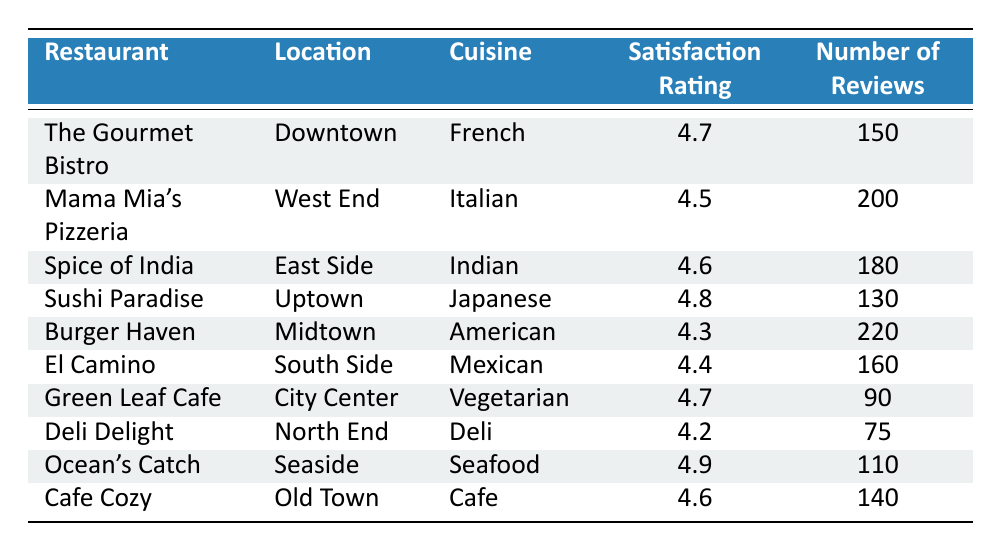What is the highest customer satisfaction rating among the restaurants? The table lists customer satisfaction ratings, and the highest value is 4.9, which is for Ocean's Catch.
Answer: 4.9 Which restaurant has the lowest number of reviews? By examining the 'Number of Reviews' column, Deli Delight has the lowest count with 75 reviews.
Answer: 75 How many more reviews does Burger Haven have compared to El Camino? Burger Haven has 220 reviews and El Camino has 160 reviews. The difference is 220 - 160 = 60 more reviews.
Answer: 60 What is the average customer satisfaction rating for all listed restaurants? The ratings are 4.7, 4.5, 4.6, 4.8, 4.3, 4.4, 4.7, 4.2, 4.9, and 4.6. Adding these (4.7 + 4.5 + 4.6 + 4.8 + 4.3 + 4.4 + 4.7 + 4.2 + 4.9 + 4.6 = 46.7) and then dividing by 10 gives us an average of 46.7 / 10 = 4.67.
Answer: 4.67 Is there any restaurant with a satisfaction rating below 4.3? The table shows all satisfaction ratings, and the lowest rating is 4.2 for Deli Delight. Therefore, there is one restaurant below 4.3.
Answer: Yes Which cuisine has the highest customer satisfaction rating? The highest rating recorded is 4.9 from Ocean's Catch, which serves Seafood.
Answer: Seafood How do the customer satisfaction ratings of vegetarian restaurants compare to those of American restaurants? Green Leaf Cafe (Vegetarian) has a rating of 4.7, while Burger Haven (American) has a rating of 4.3. Comparing these values shows that 4.7 is higher than 4.3.
Answer: Vegetarian restaurants are higher What percentage of reviews does Sushi Paradise contribute to the total number of reviews? The total number of reviews is 150 + 200 + 180 + 130 + 220 + 160 + 90 + 75 + 110 + 140 = 1,455. Sushi Paradise has 130 reviews, which is 130 / 1455 * 100 ≈ 8.93%.
Answer: Approximately 8.93% Which restaurant is located in Downtown? The table lists The Gourmet Bistro as the restaurant in Downtown.
Answer: The Gourmet Bistro Are more customers satisfied with Indian cuisine than with Deli cuisine based on the ratings? Spice of India (Indian cuisine) has a rating of 4.6 while Deli Delight (Deli cuisine) has a rating of 4.2. Since 4.6 is greater than 4.2, more customers are satisfied with Indian cuisine.
Answer: Yes 